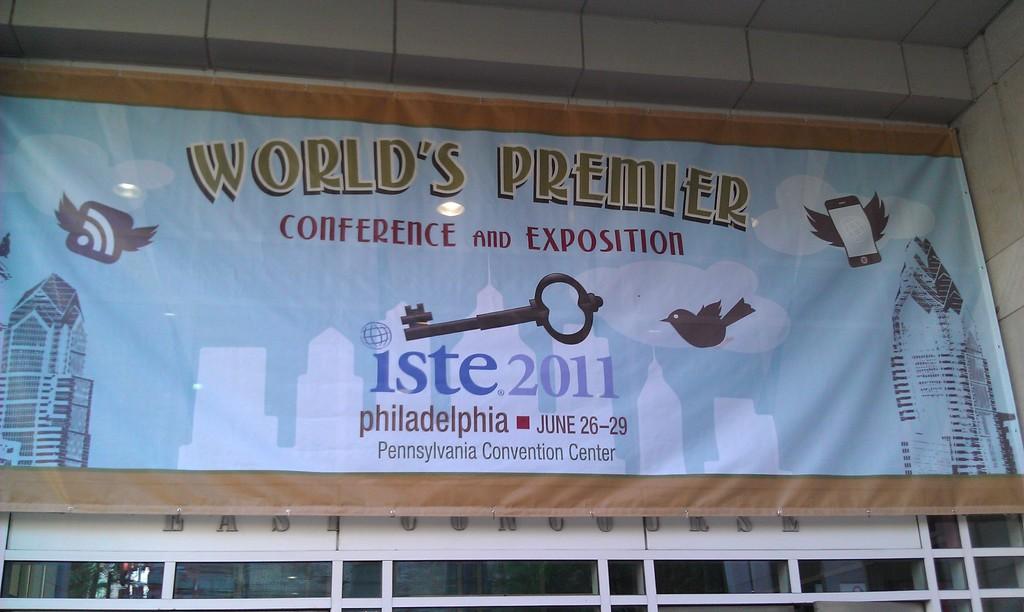Where is the event located?
Give a very brief answer. Philadelphia. What is the year on the event?
Your response must be concise. 2011. 